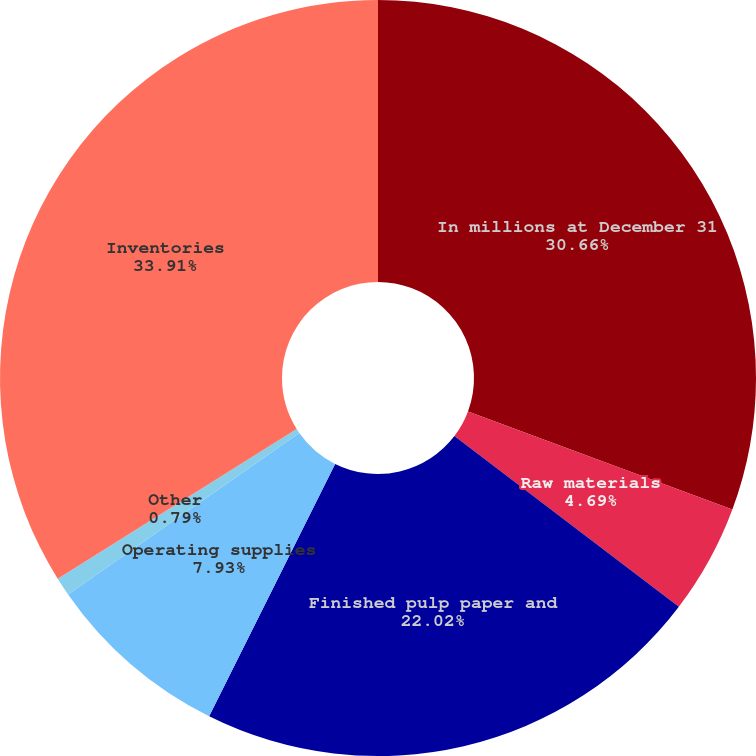Convert chart. <chart><loc_0><loc_0><loc_500><loc_500><pie_chart><fcel>In millions at December 31<fcel>Raw materials<fcel>Finished pulp paper and<fcel>Operating supplies<fcel>Other<fcel>Inventories<nl><fcel>30.66%<fcel>4.69%<fcel>22.02%<fcel>7.93%<fcel>0.79%<fcel>33.91%<nl></chart> 